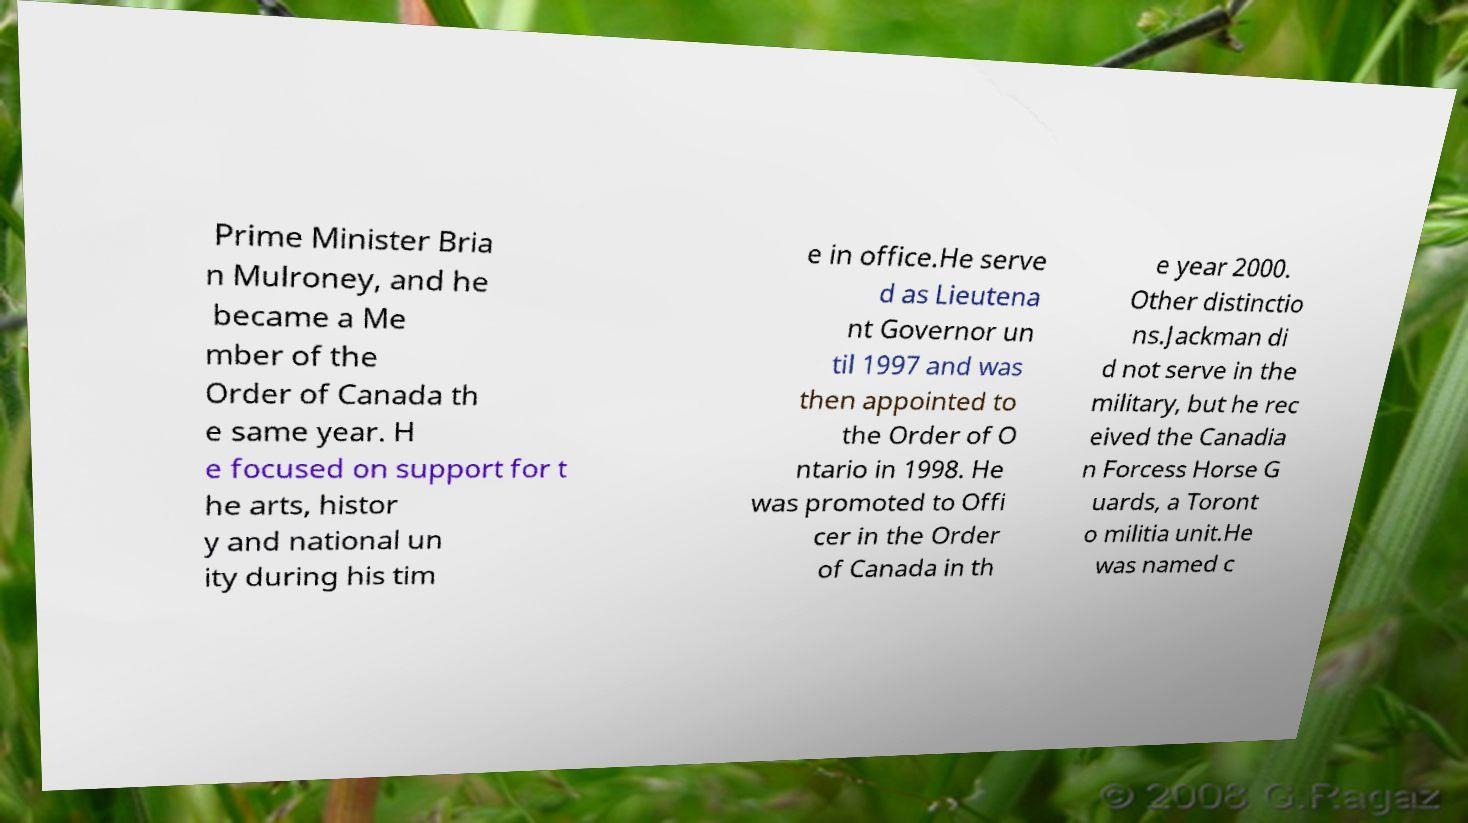Please identify and transcribe the text found in this image. Prime Minister Bria n Mulroney, and he became a Me mber of the Order of Canada th e same year. H e focused on support for t he arts, histor y and national un ity during his tim e in office.He serve d as Lieutena nt Governor un til 1997 and was then appointed to the Order of O ntario in 1998. He was promoted to Offi cer in the Order of Canada in th e year 2000. Other distinctio ns.Jackman di d not serve in the military, but he rec eived the Canadia n Forcess Horse G uards, a Toront o militia unit.He was named c 